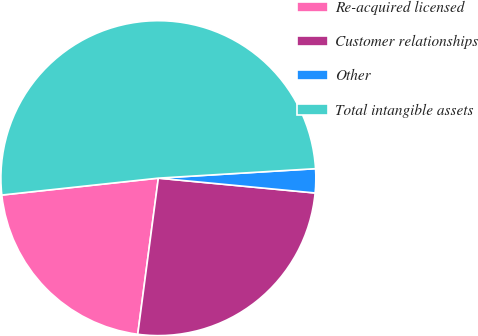Convert chart to OTSL. <chart><loc_0><loc_0><loc_500><loc_500><pie_chart><fcel>Re-acquired licensed<fcel>Customer relationships<fcel>Other<fcel>Total intangible assets<nl><fcel>21.2%<fcel>25.59%<fcel>2.46%<fcel>50.76%<nl></chart> 